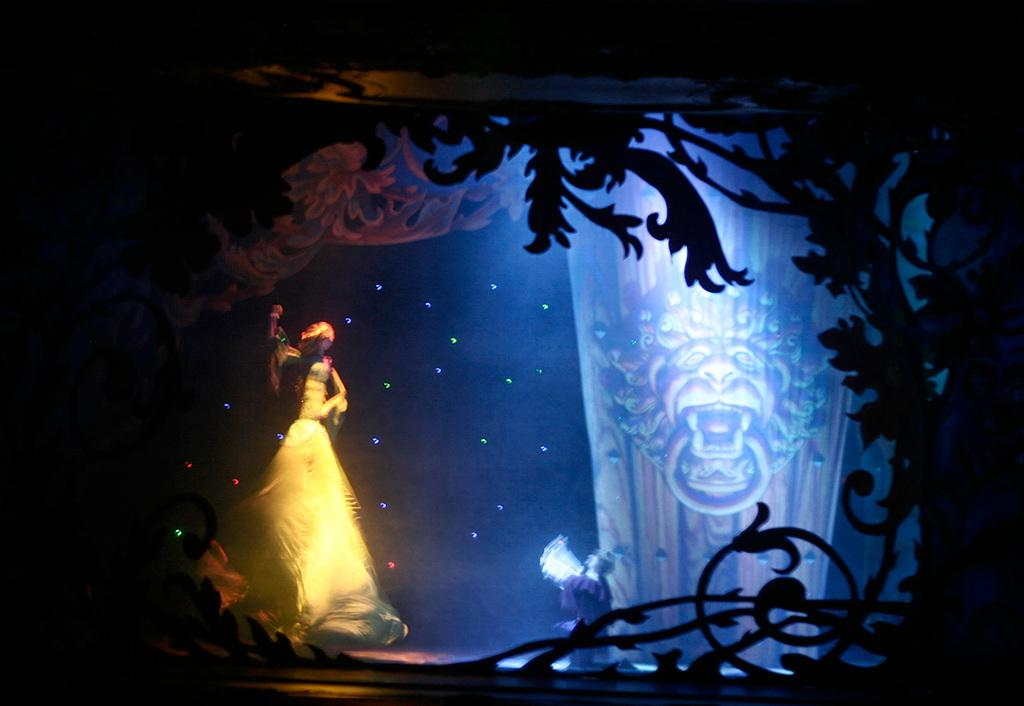What is the main subject in the center of the image? There are statues in the center of the image. What can be seen at the front of the image? There is a design in the front of the image. What is visible in the background of the image? There are tattoos visible in the background of the image. What type of root can be seen growing in the image? There is no root visible in the image. What kind of drug is being used by the boys in the image? There are no boys or drugs present in the image. 